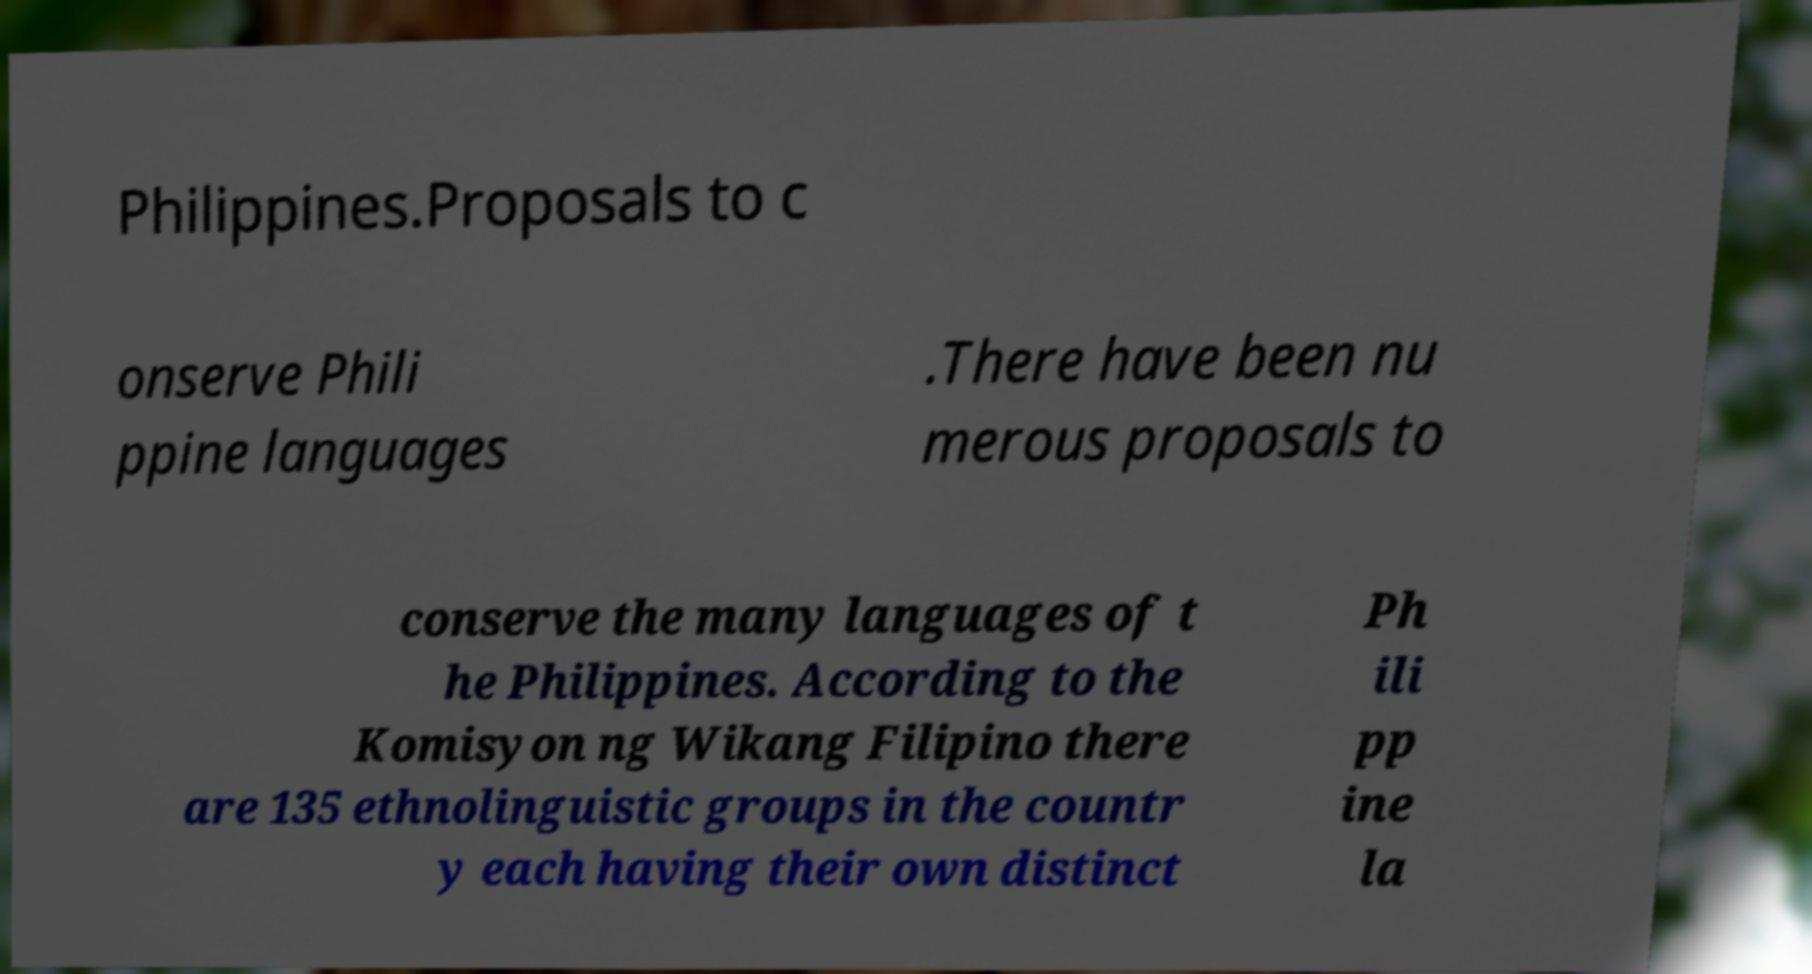There's text embedded in this image that I need extracted. Can you transcribe it verbatim? Philippines.Proposals to c onserve Phili ppine languages .There have been nu merous proposals to conserve the many languages of t he Philippines. According to the Komisyon ng Wikang Filipino there are 135 ethnolinguistic groups in the countr y each having their own distinct Ph ili pp ine la 